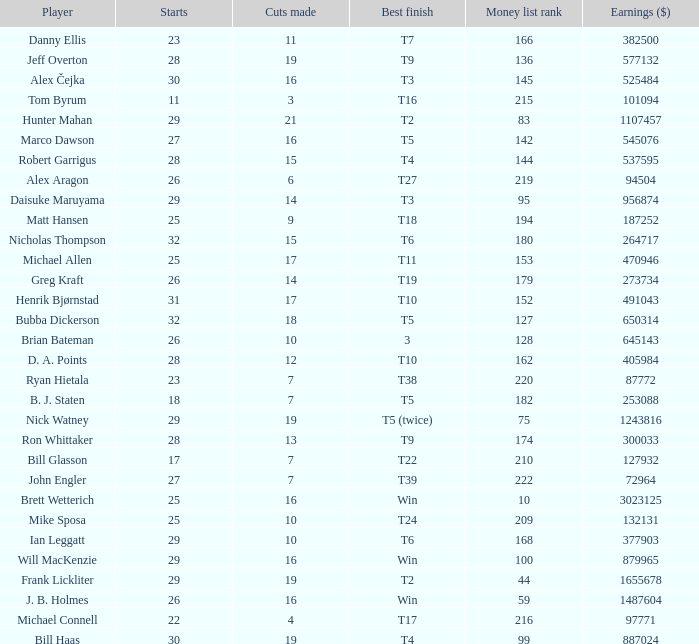What is the minimum money list rank for the players having a best finish of T9? 136.0. 